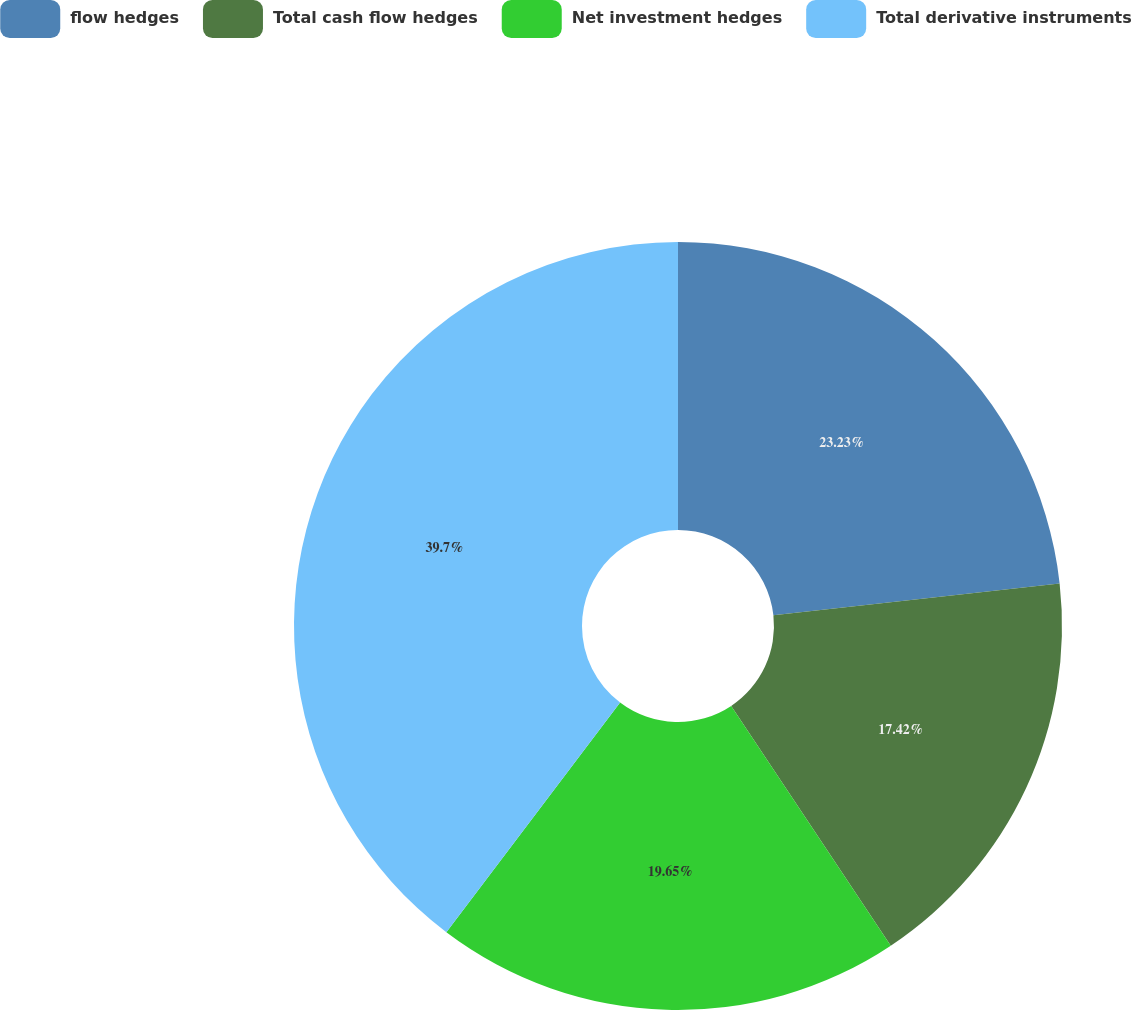<chart> <loc_0><loc_0><loc_500><loc_500><pie_chart><fcel>flow hedges<fcel>Total cash flow hedges<fcel>Net investment hedges<fcel>Total derivative instruments<nl><fcel>23.23%<fcel>17.42%<fcel>19.65%<fcel>39.69%<nl></chart> 